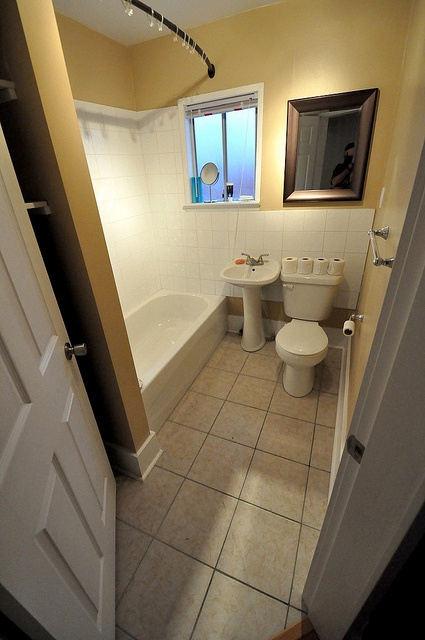Describe the objects in this image and their specific colors. I can see toilet in black, tan, and gray tones, sink in black, tan, and gray tones, and people in black tones in this image. 